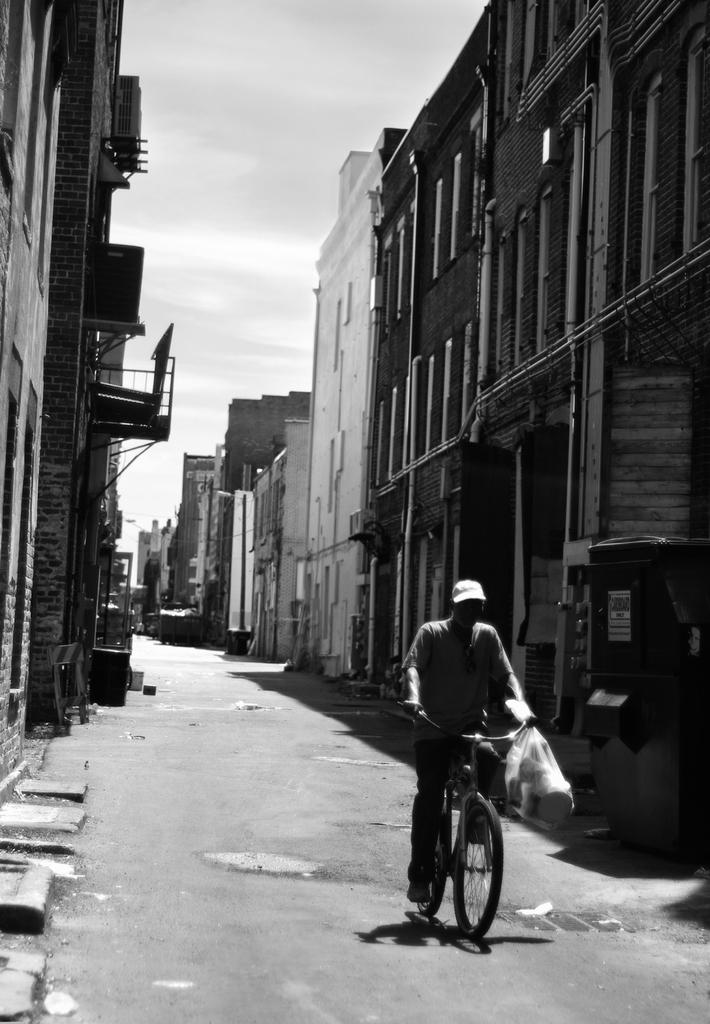What is the person in the image doing? The person is riding a bicycle on the road. What can be seen on the left side of the road? There are buildings on the left side of the road. What can be seen on the right side of the road? There are buildings on the right side of the road. What type of match is the person playing in the image? There is no match or any indication of a game in the image; it simply shows a person riding a bicycle on the road. 